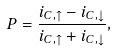<formula> <loc_0><loc_0><loc_500><loc_500>P = \frac { i _ { C , \uparrow } - i _ { C , \downarrow } } { i _ { C , \uparrow } + i _ { C , \downarrow } } ,</formula> 